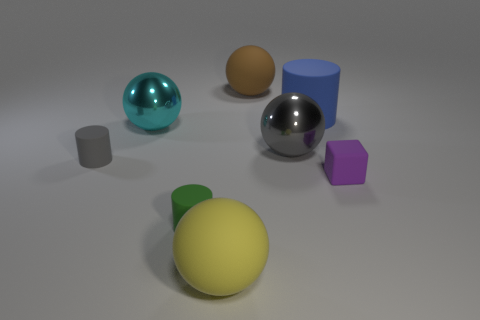Subtract all large blue rubber cylinders. How many cylinders are left? 2 Subtract all brown balls. How many balls are left? 3 Subtract 1 cylinders. How many cylinders are left? 2 Add 1 blue cubes. How many objects exist? 9 Subtract all purple balls. Subtract all blue cubes. How many balls are left? 4 Subtract all cubes. How many objects are left? 7 Subtract all large blue rubber objects. Subtract all big cyan metal objects. How many objects are left? 6 Add 2 small green rubber cylinders. How many small green rubber cylinders are left? 3 Add 3 yellow matte spheres. How many yellow matte spheres exist? 4 Subtract 1 purple cubes. How many objects are left? 7 